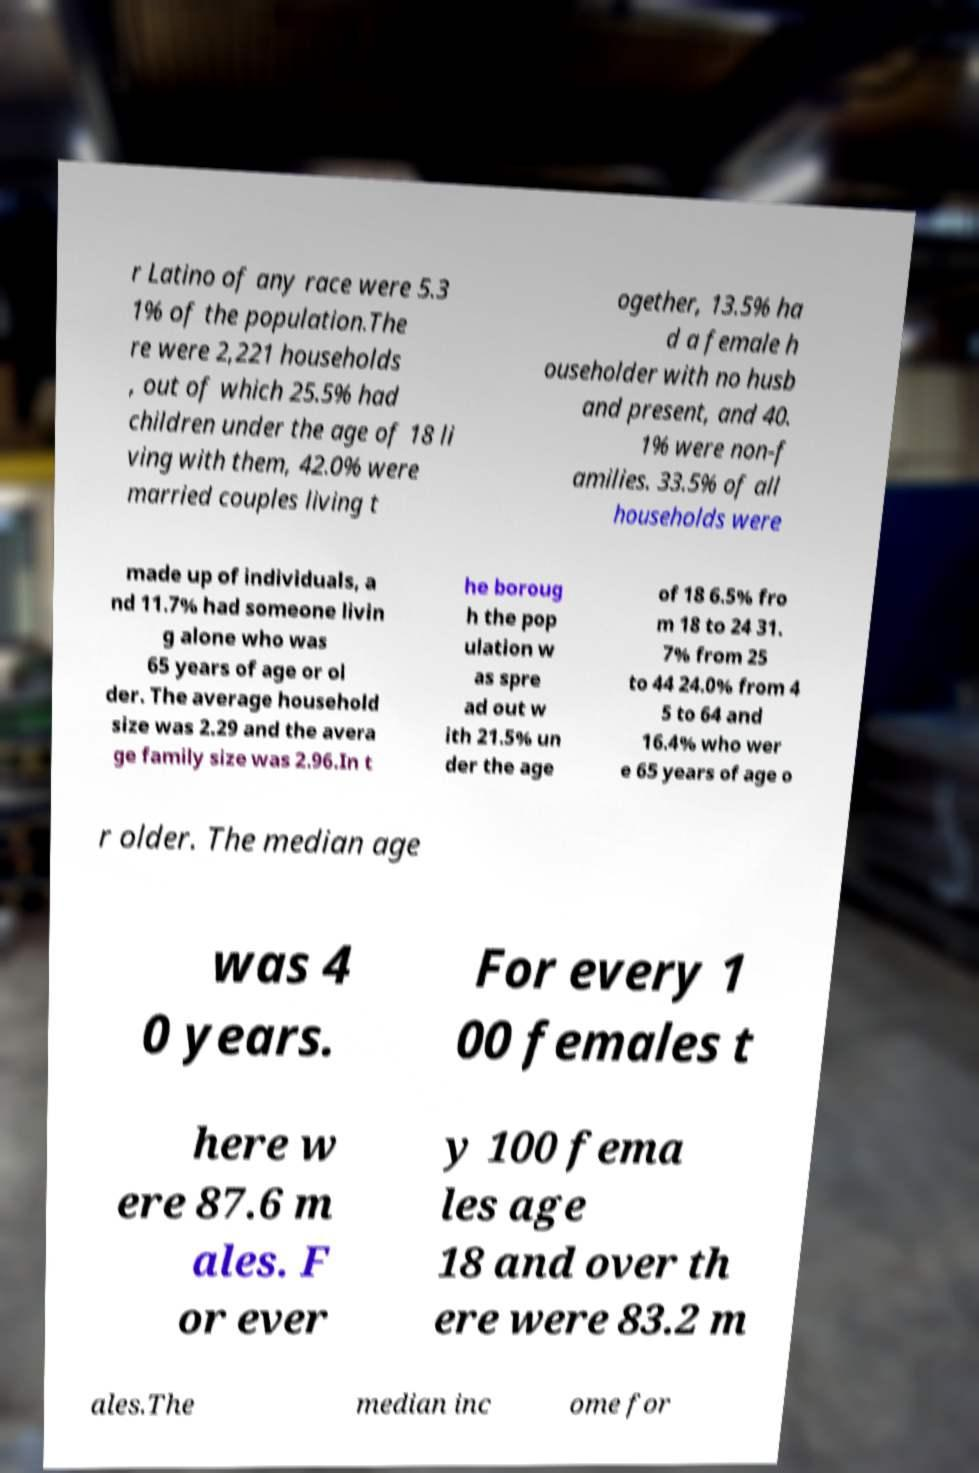Can you read and provide the text displayed in the image?This photo seems to have some interesting text. Can you extract and type it out for me? r Latino of any race were 5.3 1% of the population.The re were 2,221 households , out of which 25.5% had children under the age of 18 li ving with them, 42.0% were married couples living t ogether, 13.5% ha d a female h ouseholder with no husb and present, and 40. 1% were non-f amilies. 33.5% of all households were made up of individuals, a nd 11.7% had someone livin g alone who was 65 years of age or ol der. The average household size was 2.29 and the avera ge family size was 2.96.In t he boroug h the pop ulation w as spre ad out w ith 21.5% un der the age of 18 6.5% fro m 18 to 24 31. 7% from 25 to 44 24.0% from 4 5 to 64 and 16.4% who wer e 65 years of age o r older. The median age was 4 0 years. For every 1 00 females t here w ere 87.6 m ales. F or ever y 100 fema les age 18 and over th ere were 83.2 m ales.The median inc ome for 